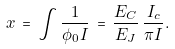<formula> <loc_0><loc_0><loc_500><loc_500>x \, = \, \int \frac { 1 } { \phi _ { 0 } I } \, = \, \frac { E _ { C } } { E _ { J } } \, \frac { I _ { c } } { \pi I } .</formula> 